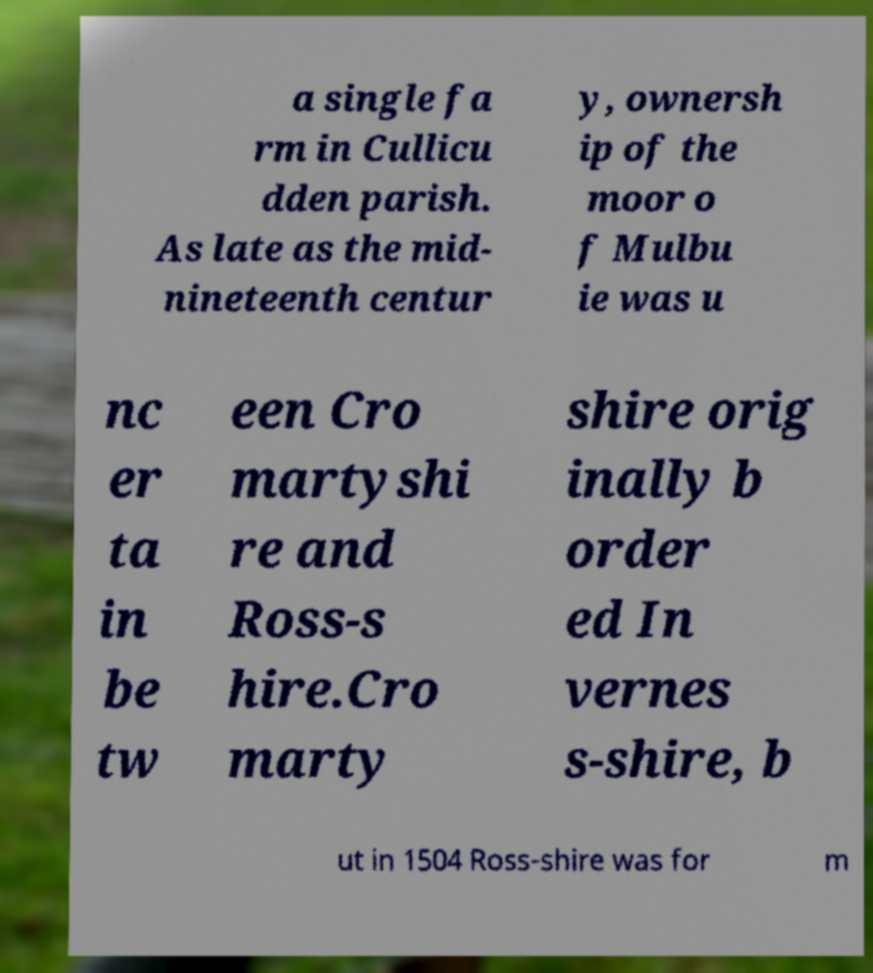Could you extract and type out the text from this image? a single fa rm in Cullicu dden parish. As late as the mid- nineteenth centur y, ownersh ip of the moor o f Mulbu ie was u nc er ta in be tw een Cro martyshi re and Ross-s hire.Cro marty shire orig inally b order ed In vernes s-shire, b ut in 1504 Ross-shire was for m 